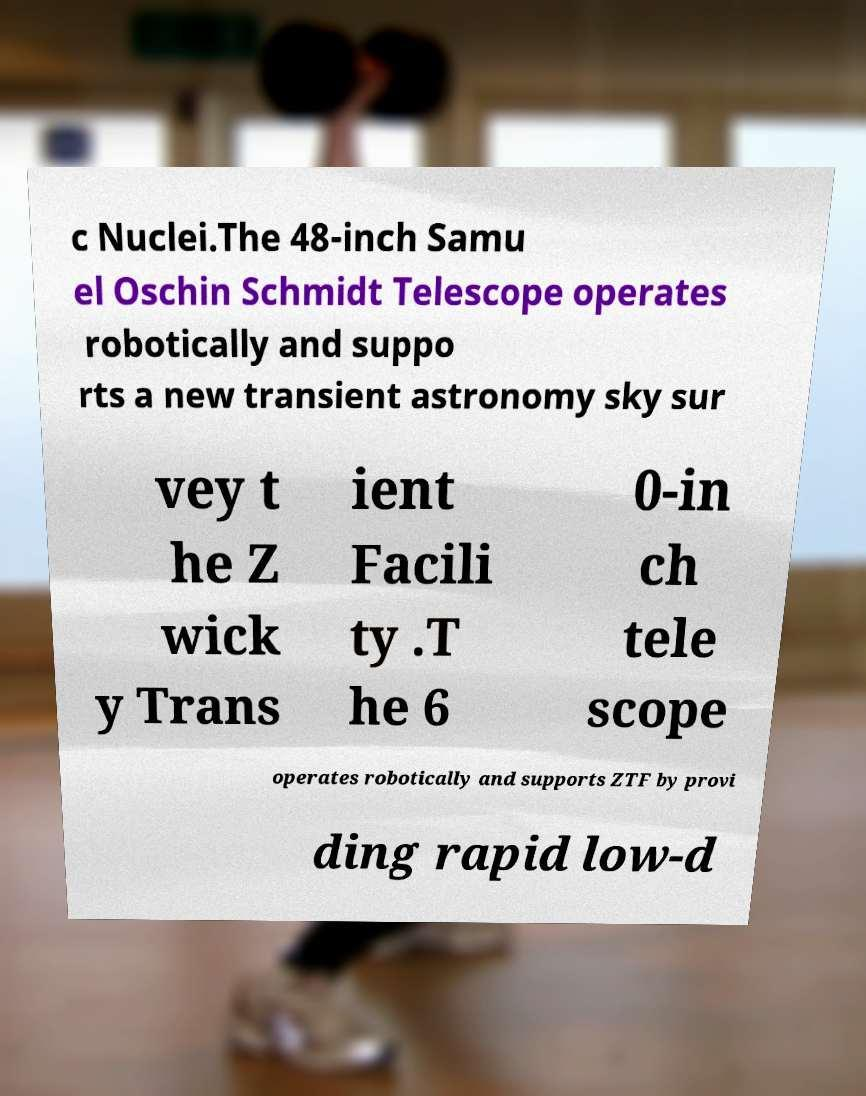Please read and relay the text visible in this image. What does it say? c Nuclei.The 48-inch Samu el Oschin Schmidt Telescope operates robotically and suppo rts a new transient astronomy sky sur vey t he Z wick y Trans ient Facili ty .T he 6 0-in ch tele scope operates robotically and supports ZTF by provi ding rapid low-d 